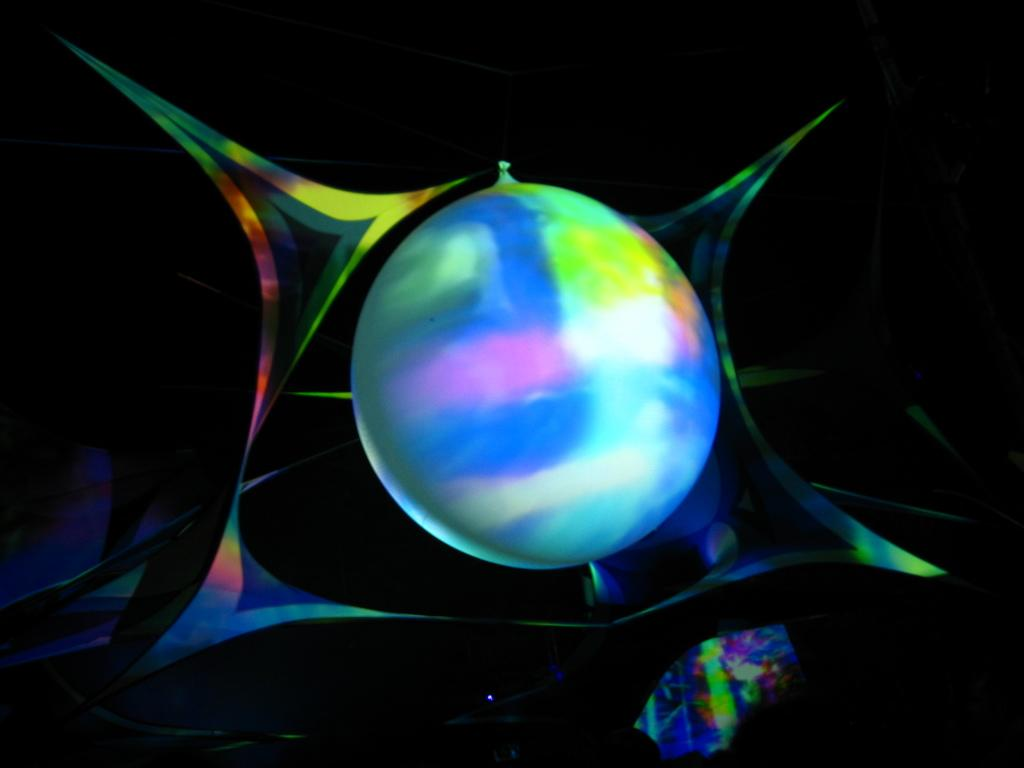What is the main subject of the image? The main subject of the image is a colorful ball. What type of honey is dripping from the chin of the person holding the ball in the image? There is no person or honey present in the image; it only features a colorful ball. 